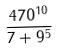<formula> <loc_0><loc_0><loc_500><loc_500>\frac { 4 7 0 ^ { 1 0 } } { 7 + 9 ^ { 5 } }</formula> 